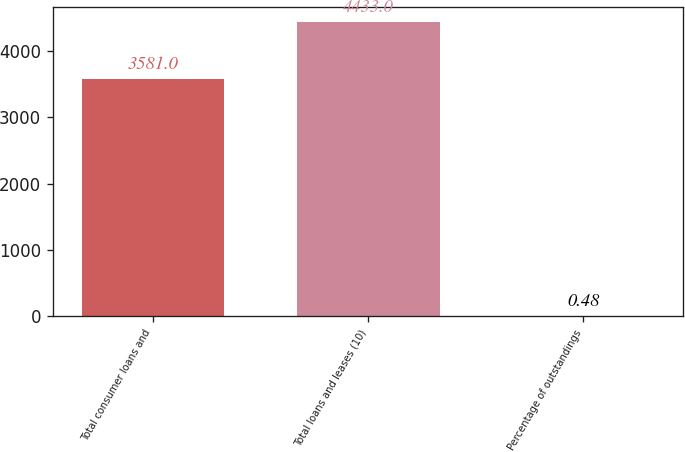Convert chart. <chart><loc_0><loc_0><loc_500><loc_500><bar_chart><fcel>Total consumer loans and<fcel>Total loans and leases (10)<fcel>Percentage of outstandings<nl><fcel>3581<fcel>4433<fcel>0.48<nl></chart> 